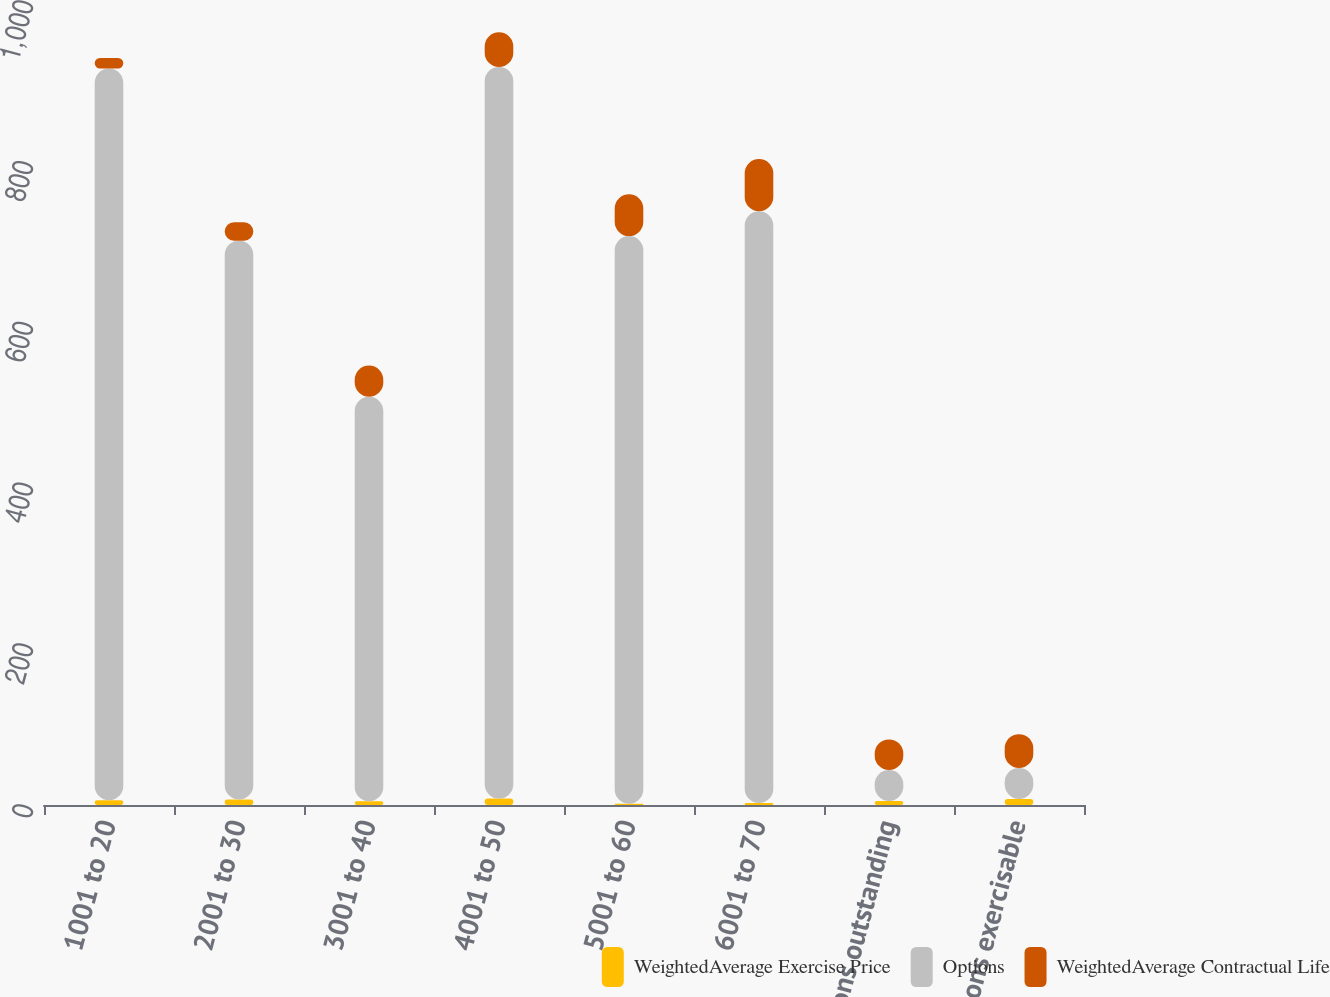Convert chart. <chart><loc_0><loc_0><loc_500><loc_500><stacked_bar_chart><ecel><fcel>1001 to 20<fcel>2001 to 30<fcel>3001 to 40<fcel>4001 to 50<fcel>5001 to 60<fcel>6001 to 70<fcel>Options outstanding<fcel>Options exercisable<nl><fcel>WeightedAverage Exercise Price<fcel>6<fcel>6.9<fcel>4.7<fcel>8<fcel>1.6<fcel>2.5<fcel>5.1<fcel>7.6<nl><fcel>Options<fcel>910<fcel>695<fcel>503<fcel>910<fcel>706<fcel>736<fcel>38.5<fcel>38.5<nl><fcel>WeightedAverage Contractual Life<fcel>13<fcel>23<fcel>39<fcel>43<fcel>52<fcel>65<fcel>38<fcel>42<nl></chart> 